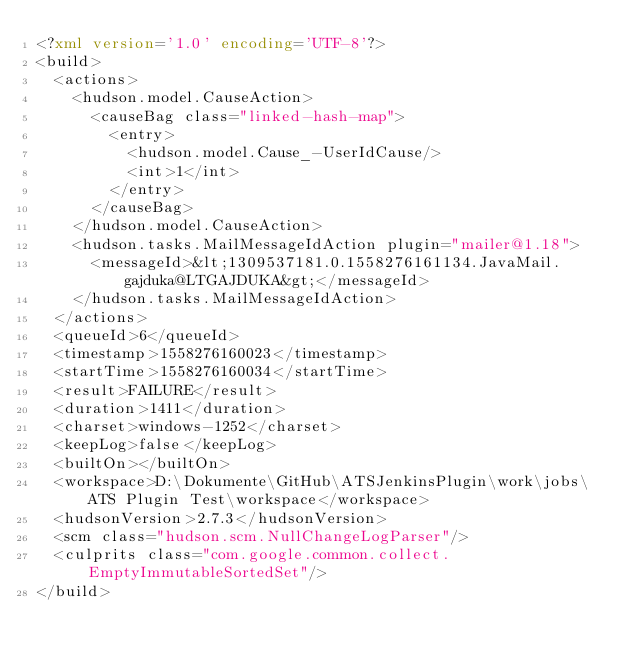<code> <loc_0><loc_0><loc_500><loc_500><_XML_><?xml version='1.0' encoding='UTF-8'?>
<build>
  <actions>
    <hudson.model.CauseAction>
      <causeBag class="linked-hash-map">
        <entry>
          <hudson.model.Cause_-UserIdCause/>
          <int>1</int>
        </entry>
      </causeBag>
    </hudson.model.CauseAction>
    <hudson.tasks.MailMessageIdAction plugin="mailer@1.18">
      <messageId>&lt;1309537181.0.1558276161134.JavaMail.gajduka@LTGAJDUKA&gt;</messageId>
    </hudson.tasks.MailMessageIdAction>
  </actions>
  <queueId>6</queueId>
  <timestamp>1558276160023</timestamp>
  <startTime>1558276160034</startTime>
  <result>FAILURE</result>
  <duration>1411</duration>
  <charset>windows-1252</charset>
  <keepLog>false</keepLog>
  <builtOn></builtOn>
  <workspace>D:\Dokumente\GitHub\ATSJenkinsPlugin\work\jobs\ATS Plugin Test\workspace</workspace>
  <hudsonVersion>2.7.3</hudsonVersion>
  <scm class="hudson.scm.NullChangeLogParser"/>
  <culprits class="com.google.common.collect.EmptyImmutableSortedSet"/>
</build></code> 